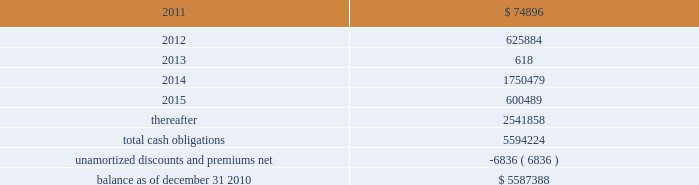American tower corporation and subsidiaries notes to consolidated financial statements as of december 31 , 2010 and 2009 , the company had $ 295.4 million and $ 295.0 million net , respectively ( $ 300.0 million aggregate principal amount ) outstanding under the 7.25% ( 7.25 % ) notes .
As of december 31 , 2010 and 2009 , the carrying value includes a discount of $ 4.6 million and $ 5.0 million , respectively .
5.0% ( 5.0 % ) convertible notes 2014the 5.0% ( 5.0 % ) convertible notes due 2010 ( 201c5.0% ( 201c5.0 % ) notes 201d ) matured on february 15 , 2010 , and interest was payable semiannually on february 15 and august 15 of each year .
The 5.0% ( 5.0 % ) notes were convertible at any time into shares of the company 2019s class a common stock ( 201ccommon stock 201d ) at a conversion price of $ 51.50 per share , subject to adjustment in certain cases .
As of december 31 , 2010 and 2009 , the company had none and $ 59.7 million outstanding , respectively , under the 5.0% ( 5.0 % ) notes .
Ati 7.25% ( 7.25 % ) senior subordinated notes 2014the ati 7.25% ( 7.25 % ) notes were issued with a maturity of december 1 , 2011 and interest was payable semi-annually in arrears on june 1 and december 1 of each year .
The ati 7.25% ( 7.25 % ) notes were jointly and severally guaranteed on a senior subordinated basis by the company and substantially all of the wholly owned domestic restricted subsidiaries of ati and the company , other than spectrasite and its subsidiaries .
The notes ranked junior in right of payment to all existing and future senior indebtedness of ati , the sister guarantors ( as defined in the indenture relating to the notes ) and their domestic restricted subsidiaries .
The ati 7.25% ( 7.25 % ) notes were structurally senior in right of payment to all other existing and future indebtedness of the company , including the company 2019s senior notes , convertible notes and the revolving credit facility and term loan .
During the year ended december 31 , 2010 , ati issued a notice for the redemption of the principal amount of its outstanding ati 7.25% ( 7.25 % ) notes .
In accordance with the redemption provisions and the indenture for the ati 7.25% ( 7.25 % ) notes , the notes were redeemed at a price equal to 100.00% ( 100.00 % ) of the principal amount , plus accrued and unpaid interest up to , but excluding , september 23 , 2010 , for an aggregate purchase price of $ 0.3 million .
As of december 31 , 2010 and 2009 , the company had none and $ 0.3 million , respectively , outstanding under the ati 7.25% ( 7.25 % ) notes .
Capital lease obligations and notes payable 2014the company 2019s capital lease obligations and notes payable approximated $ 46.3 million and $ 59.0 million as of december 31 , 2010 and 2009 , respectively .
These obligations bear interest at rates ranging from 2.5% ( 2.5 % ) to 9.3% ( 9.3 % ) and mature in periods ranging from less than one year to approximately seventy years .
Maturities 2014as of december 31 , 2010 , aggregate carrying value of long-term debt , including capital leases , for the next five years and thereafter are estimated to be ( in thousands ) : year ending december 31 .

What is the percentage change in the balance of capital lease obligations and notes payable from 2009 to 2010? 
Computations: ((46.3 - 59.0) / 59.0)
Answer: -0.21525. 